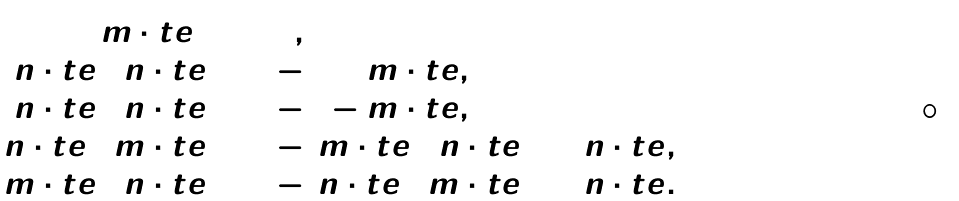Convert formula to latex. <formula><loc_0><loc_0><loc_500><loc_500>\begin{array} { r l } ( \tilde { m } \cdot t e ) ^ { 2 } & = 1 , \\ ( \tilde { n } \cdot t e ) ( n \cdot t e ) & = - 1 + \tilde { m } \cdot t e , \\ ( n \cdot t e ) ( \tilde { n } \cdot t e ) & = - 1 - \tilde { m } \cdot t e , \\ ( \tilde { n } \cdot t e ) ( \tilde { m } \cdot t e ) & = - ( \tilde { m } \cdot t e ) ( \tilde { n } \cdot t e ) = \tilde { n } \cdot t e , \\ ( \tilde { m } \cdot t e ) ( n \cdot t e ) & = - ( n \cdot t e ) ( \tilde { m } \cdot t e ) = n \cdot t e . \end{array}</formula> 